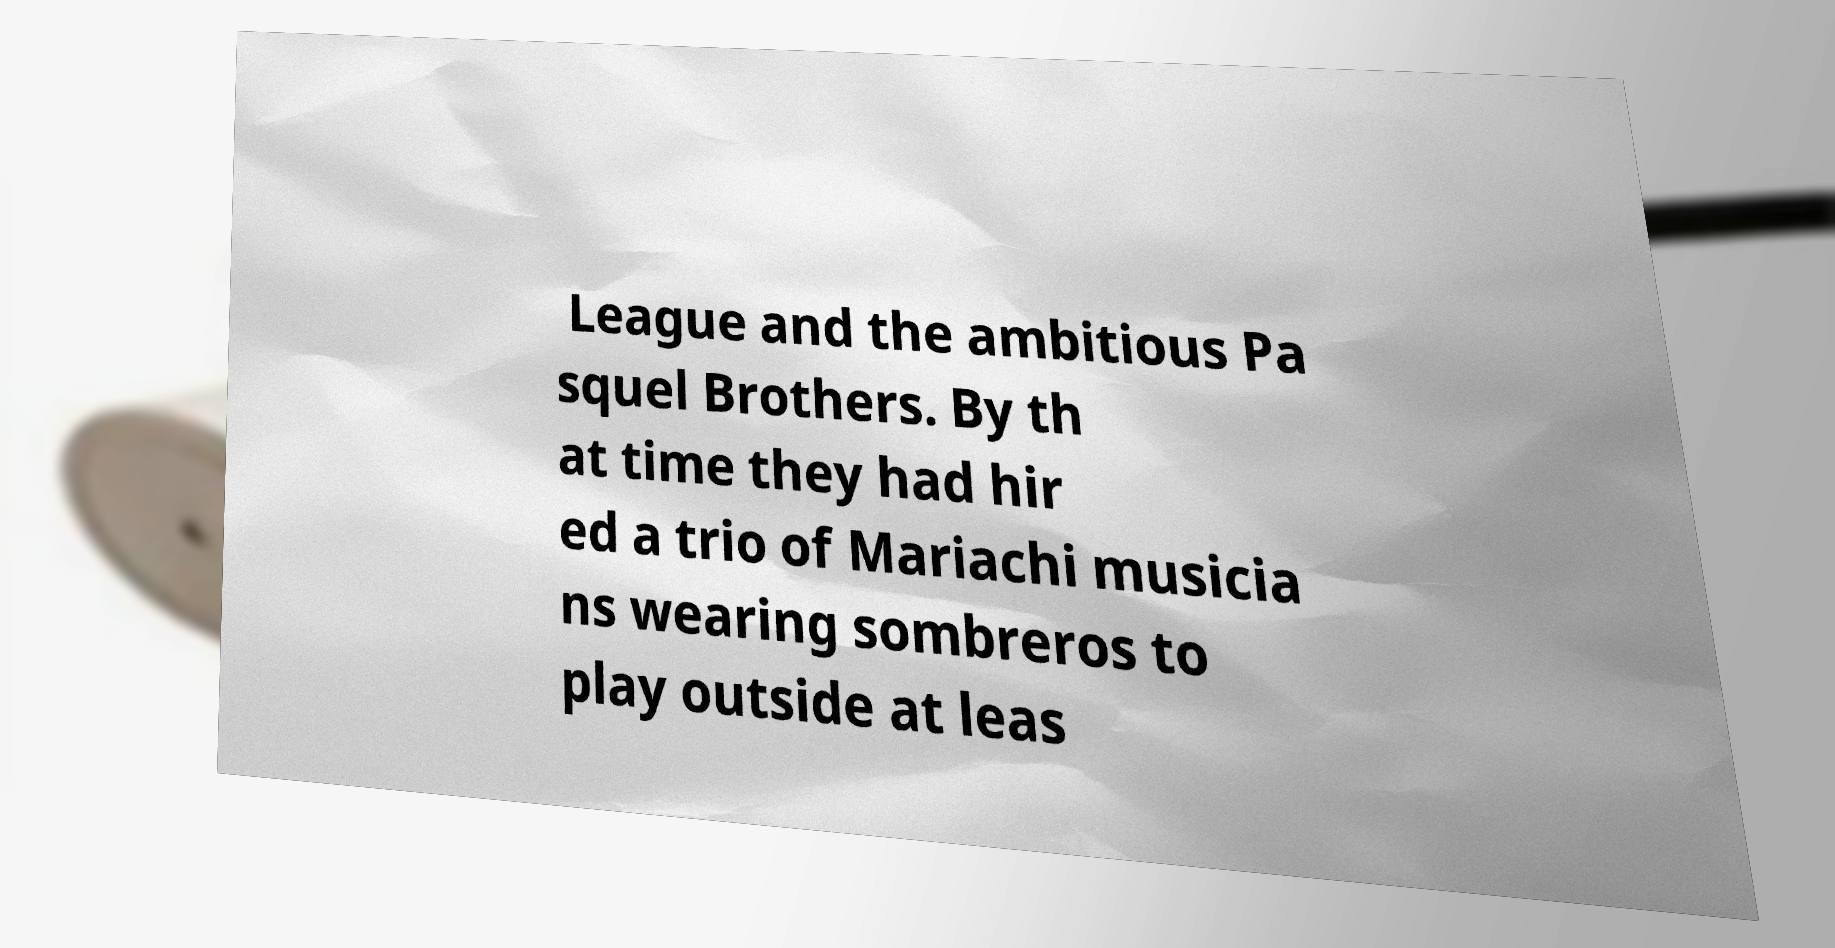I need the written content from this picture converted into text. Can you do that? League and the ambitious Pa squel Brothers. By th at time they had hir ed a trio of Mariachi musicia ns wearing sombreros to play outside at leas 